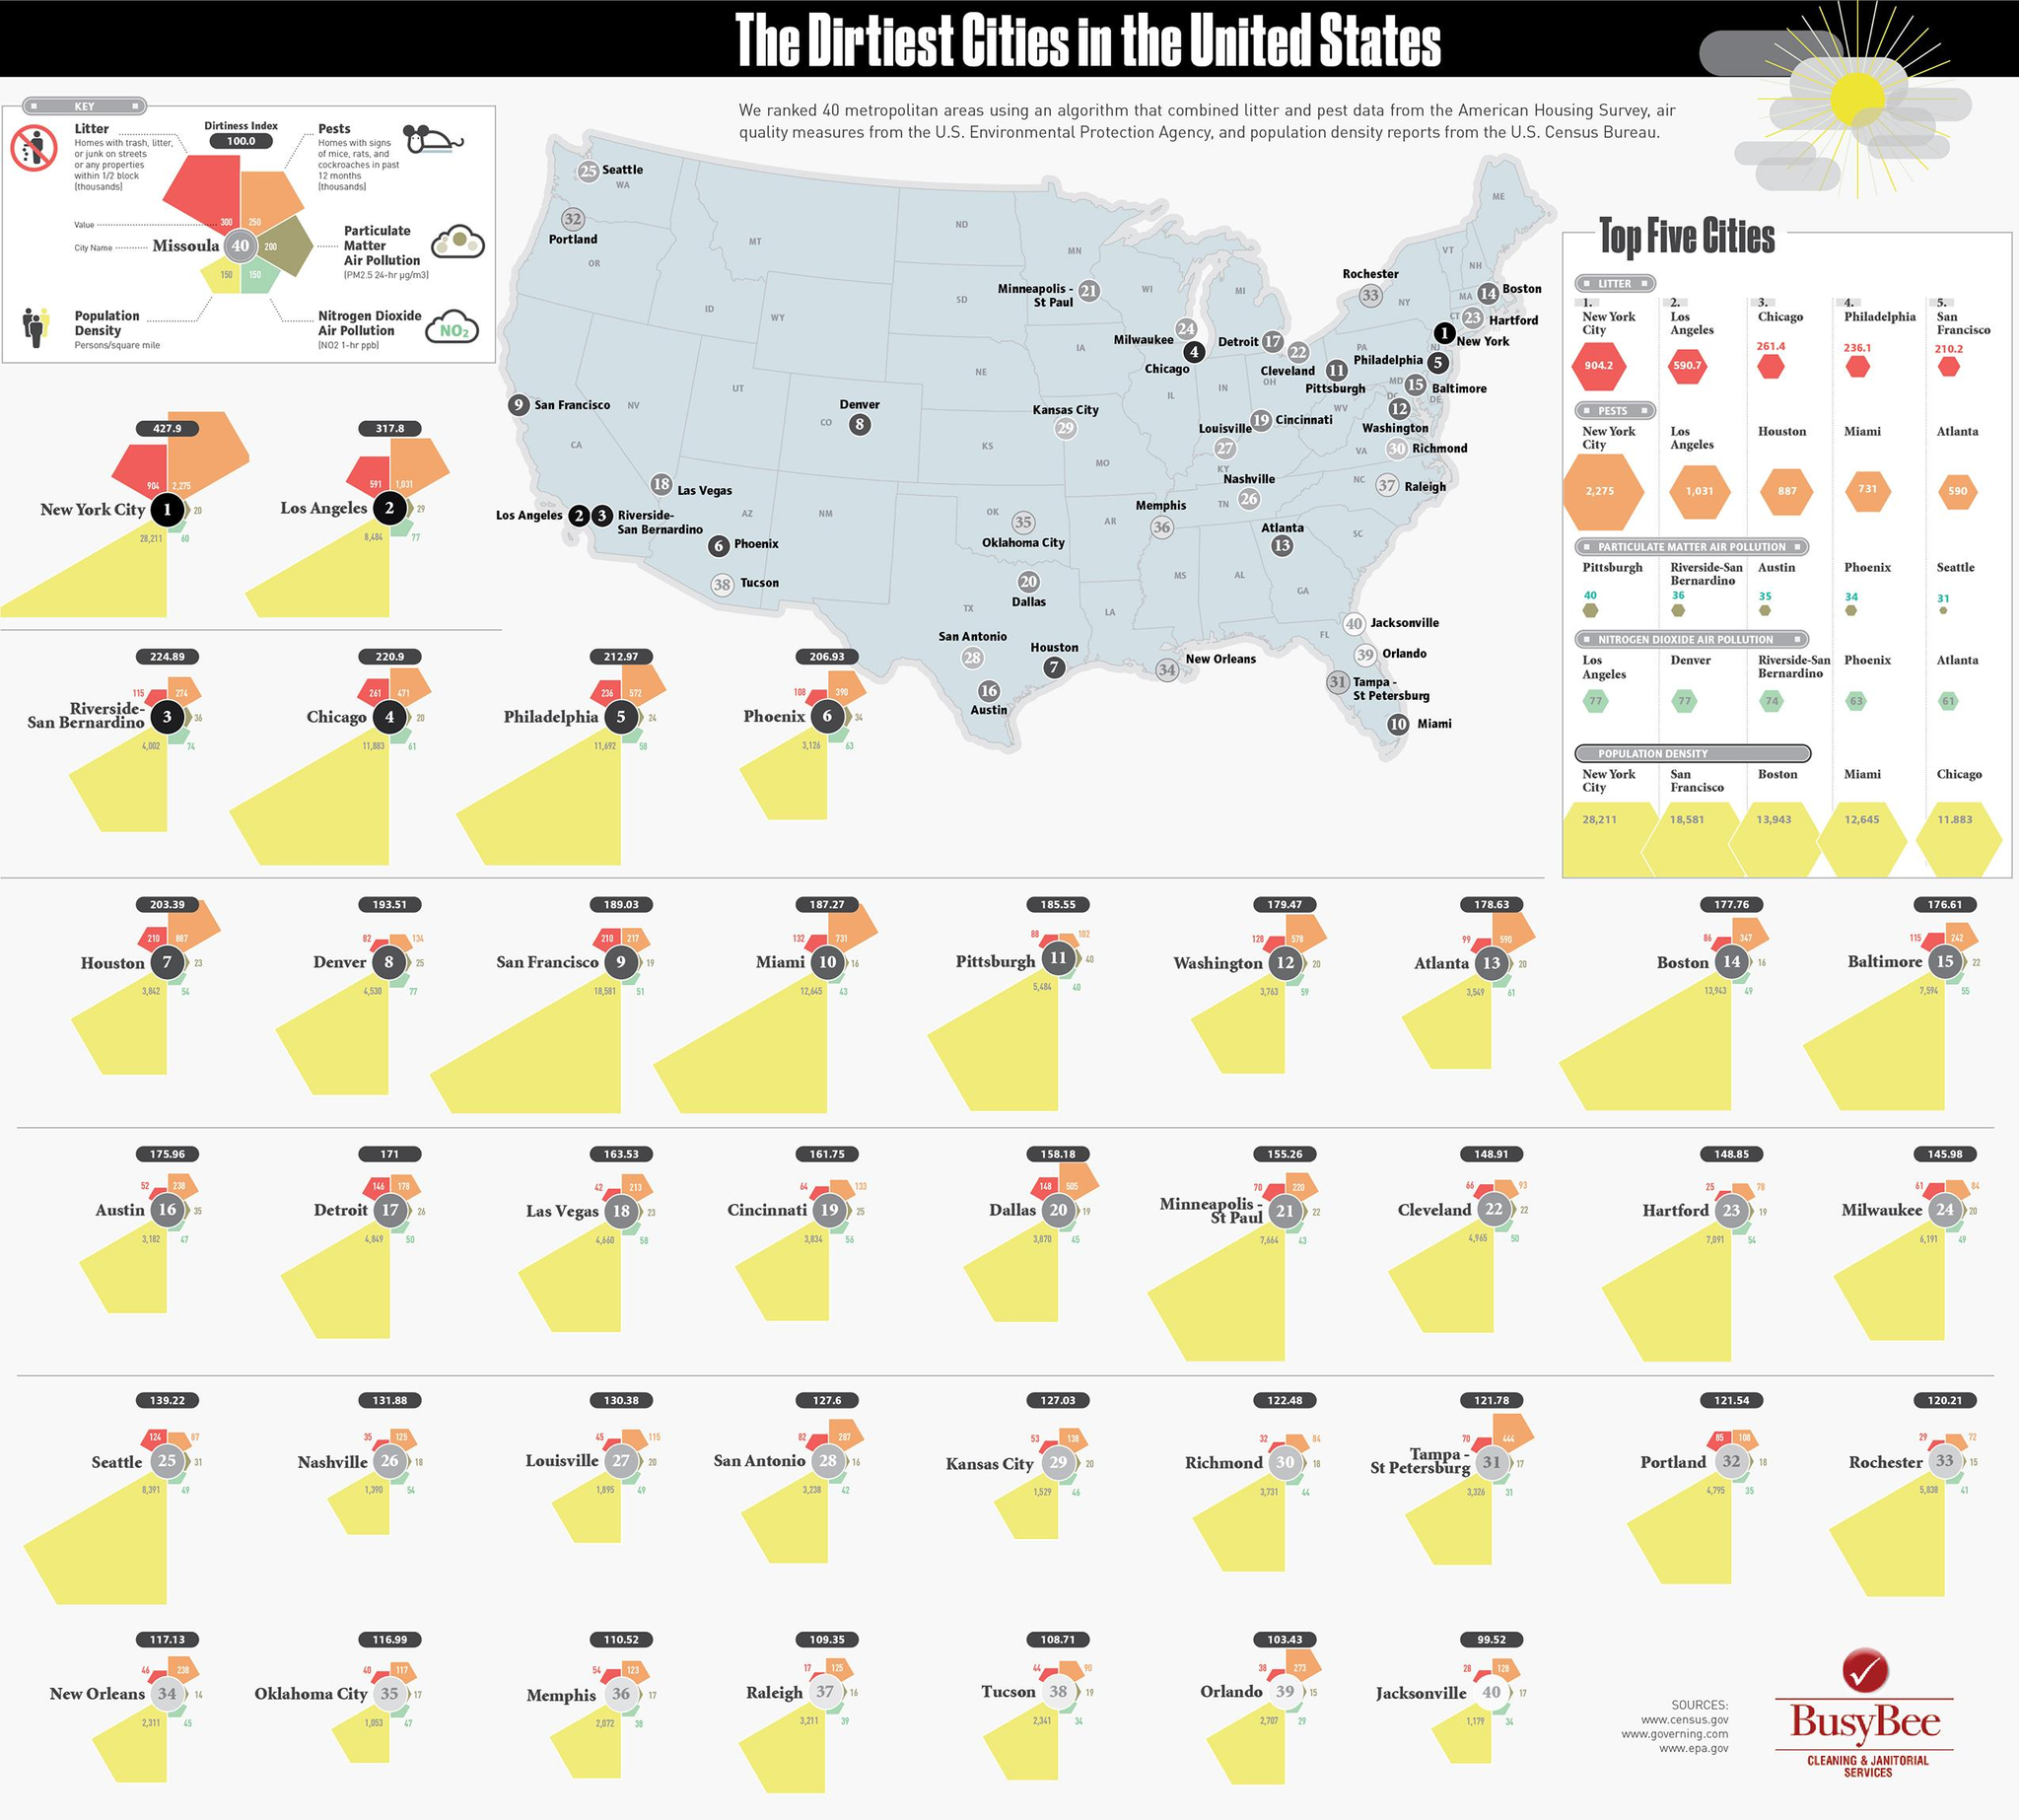Indicate a few pertinent items in this graphic. The city with the second highest level of nitrogen dioxide air pollution is Denver. The value corresponding to pests for Tucson is 90%. This means that 90% of the residents in Tucson consider pests to be a significant problem in their area. The dirtiness index value for Atlanta is 178.63, indicating a moderate level of air pollution. The nitrogen dioxide air pollution level in Kansas City is 46. The particulate matter air pollution value for Dallas is [19]. 